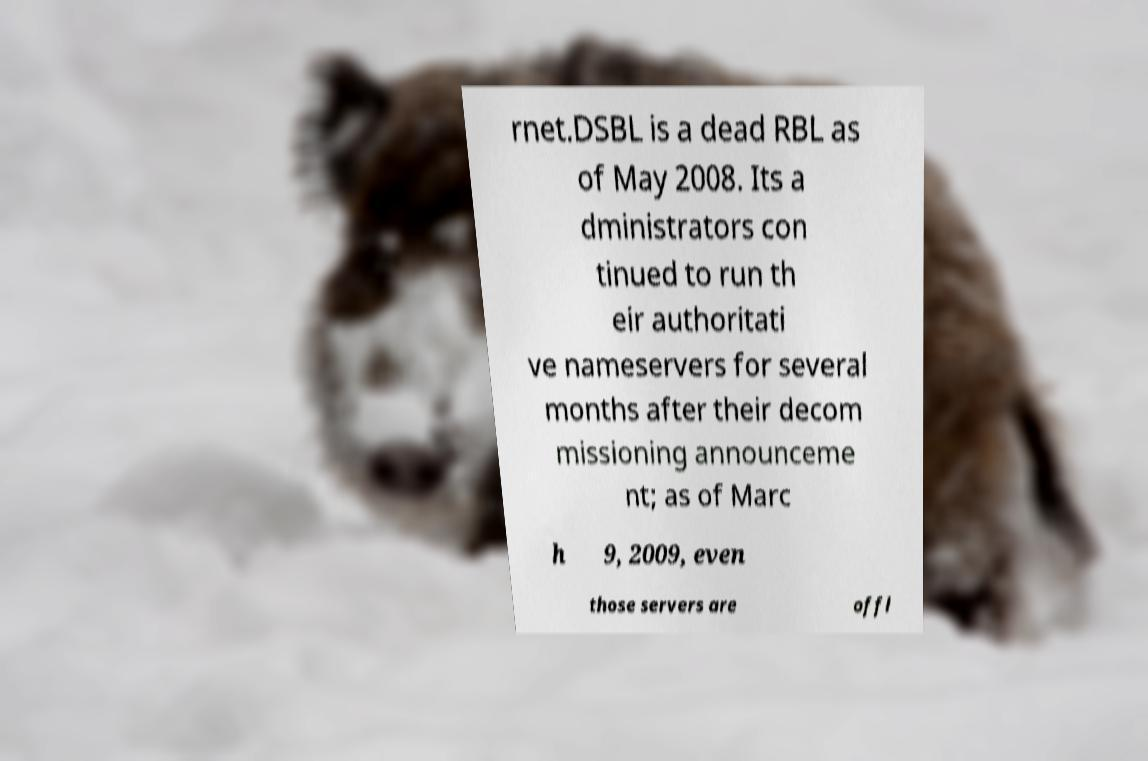There's text embedded in this image that I need extracted. Can you transcribe it verbatim? rnet.DSBL is a dead RBL as of May 2008. Its a dministrators con tinued to run th eir authoritati ve nameservers for several months after their decom missioning announceme nt; as of Marc h 9, 2009, even those servers are offl 